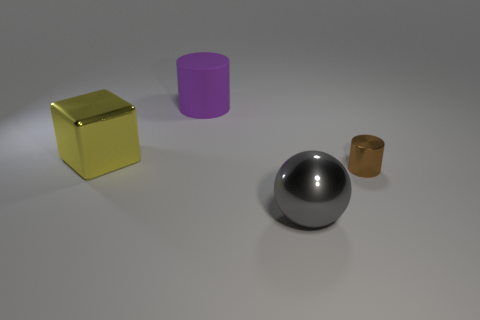Is there any other thing that is the same material as the large purple object?
Your answer should be very brief. No. There is a yellow object that is the same material as the big ball; what is its size?
Ensure brevity in your answer.  Large. What color is the big metal object that is on the right side of the large metal thing that is behind the brown cylinder?
Ensure brevity in your answer.  Gray. How many tiny brown spheres have the same material as the brown cylinder?
Give a very brief answer. 0. How many metal things are either big purple cylinders or cubes?
Provide a succinct answer. 1. There is a ball that is the same size as the purple object; what is its material?
Provide a short and direct response. Metal. Is there a brown thing that has the same material as the large gray thing?
Offer a very short reply. Yes. There is a large thing behind the large metal thing to the left of the cylinder behind the small metal cylinder; what shape is it?
Provide a short and direct response. Cylinder. There is a sphere; is its size the same as the thing to the left of the large purple matte cylinder?
Make the answer very short. Yes. There is a thing that is both in front of the large purple cylinder and on the left side of the big gray metal sphere; what is its shape?
Your response must be concise. Cube. 